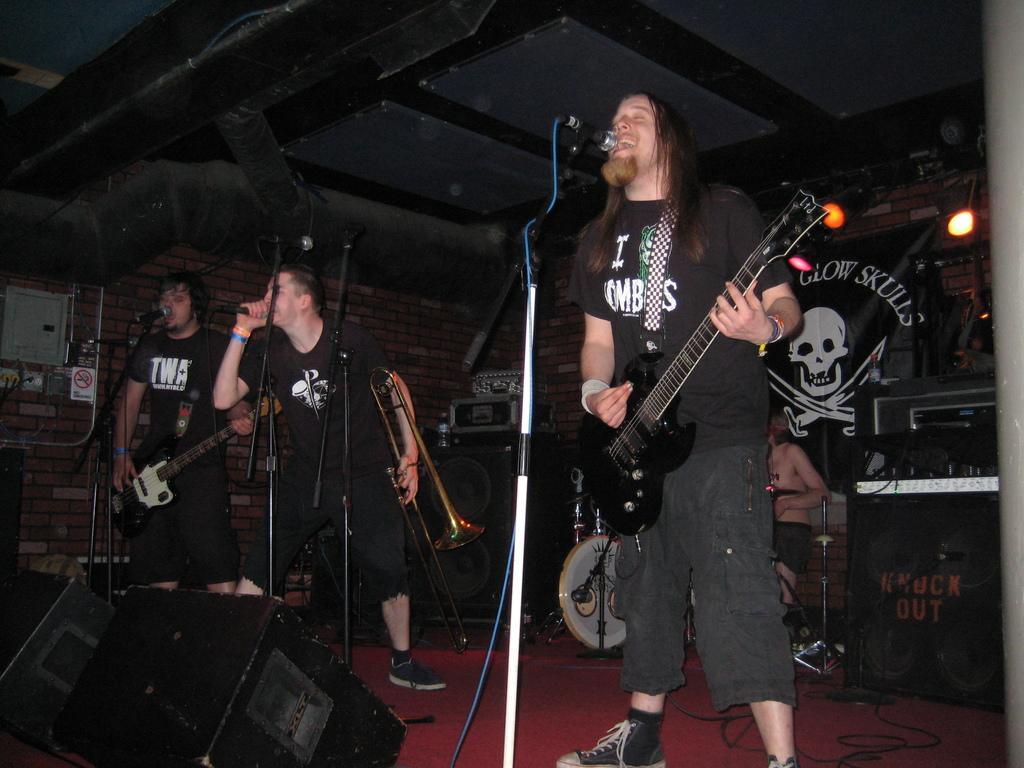Describe this image in one or two sentences. This is the image of a musical band. There are people playing musical instruments. There are mics in front of them. They all are singing. Two of them are playing guitar. One man in the middle is holding a trumpet. Behind a person is playing drums. In the background there is banner, lights, musical instruments. In the bottom left there is speaker. On the top there is a roof. 